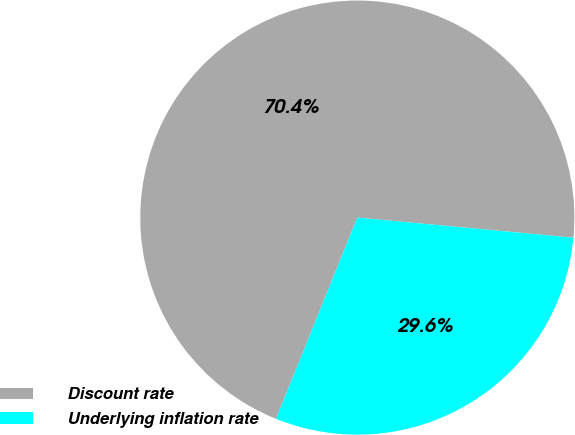Convert chart. <chart><loc_0><loc_0><loc_500><loc_500><pie_chart><fcel>Discount rate<fcel>Underlying inflation rate<nl><fcel>70.37%<fcel>29.63%<nl></chart> 